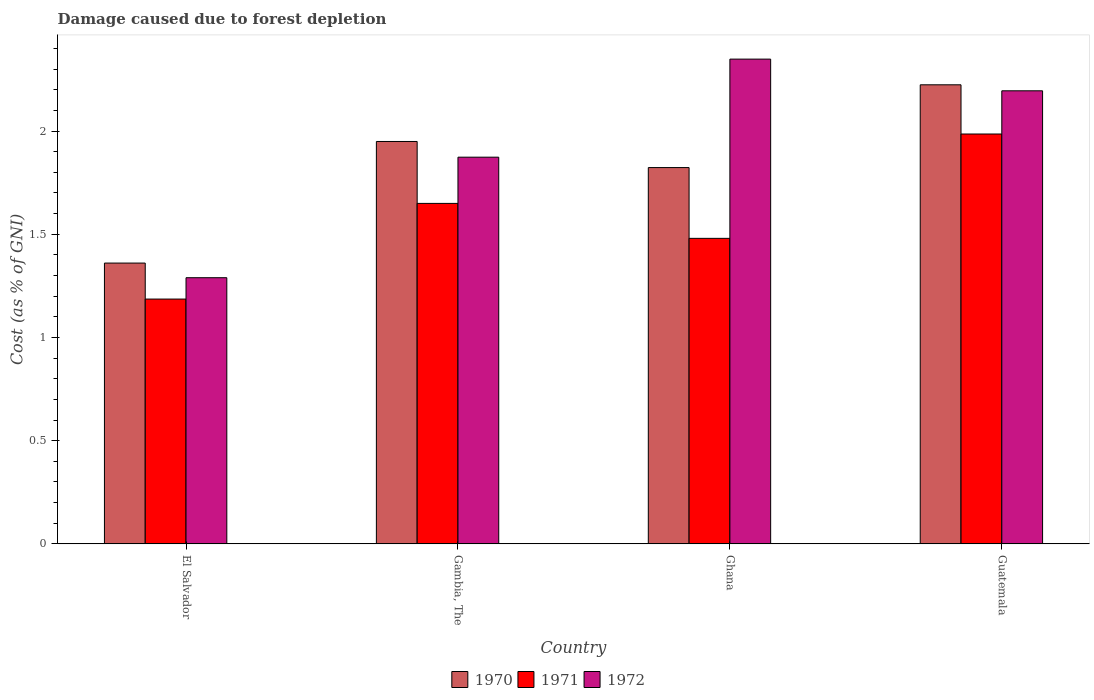How many different coloured bars are there?
Provide a short and direct response. 3. How many groups of bars are there?
Keep it short and to the point. 4. Are the number of bars per tick equal to the number of legend labels?
Keep it short and to the point. Yes. Are the number of bars on each tick of the X-axis equal?
Ensure brevity in your answer.  Yes. How many bars are there on the 4th tick from the left?
Your answer should be very brief. 3. What is the label of the 2nd group of bars from the left?
Give a very brief answer. Gambia, The. In how many cases, is the number of bars for a given country not equal to the number of legend labels?
Make the answer very short. 0. What is the cost of damage caused due to forest depletion in 1970 in Gambia, The?
Your answer should be very brief. 1.95. Across all countries, what is the maximum cost of damage caused due to forest depletion in 1971?
Offer a very short reply. 1.99. Across all countries, what is the minimum cost of damage caused due to forest depletion in 1972?
Your answer should be compact. 1.29. In which country was the cost of damage caused due to forest depletion in 1971 maximum?
Make the answer very short. Guatemala. In which country was the cost of damage caused due to forest depletion in 1971 minimum?
Ensure brevity in your answer.  El Salvador. What is the total cost of damage caused due to forest depletion in 1971 in the graph?
Your answer should be very brief. 6.3. What is the difference between the cost of damage caused due to forest depletion in 1971 in Ghana and that in Guatemala?
Ensure brevity in your answer.  -0.51. What is the difference between the cost of damage caused due to forest depletion in 1970 in Gambia, The and the cost of damage caused due to forest depletion in 1972 in El Salvador?
Keep it short and to the point. 0.66. What is the average cost of damage caused due to forest depletion in 1971 per country?
Keep it short and to the point. 1.58. What is the difference between the cost of damage caused due to forest depletion of/in 1971 and cost of damage caused due to forest depletion of/in 1970 in Guatemala?
Provide a short and direct response. -0.24. What is the ratio of the cost of damage caused due to forest depletion in 1972 in Gambia, The to that in Guatemala?
Your answer should be very brief. 0.85. Is the cost of damage caused due to forest depletion in 1970 in Ghana less than that in Guatemala?
Provide a succinct answer. Yes. What is the difference between the highest and the second highest cost of damage caused due to forest depletion in 1970?
Your response must be concise. -0.27. What is the difference between the highest and the lowest cost of damage caused due to forest depletion in 1970?
Your response must be concise. 0.86. Is the sum of the cost of damage caused due to forest depletion in 1972 in Gambia, The and Guatemala greater than the maximum cost of damage caused due to forest depletion in 1971 across all countries?
Keep it short and to the point. Yes. What does the 2nd bar from the right in El Salvador represents?
Provide a short and direct response. 1971. Is it the case that in every country, the sum of the cost of damage caused due to forest depletion in 1971 and cost of damage caused due to forest depletion in 1972 is greater than the cost of damage caused due to forest depletion in 1970?
Give a very brief answer. Yes. How many bars are there?
Provide a succinct answer. 12. Are all the bars in the graph horizontal?
Your answer should be very brief. No. How many countries are there in the graph?
Your answer should be compact. 4. What is the difference between two consecutive major ticks on the Y-axis?
Provide a succinct answer. 0.5. How many legend labels are there?
Your response must be concise. 3. What is the title of the graph?
Give a very brief answer. Damage caused due to forest depletion. What is the label or title of the X-axis?
Give a very brief answer. Country. What is the label or title of the Y-axis?
Provide a short and direct response. Cost (as % of GNI). What is the Cost (as % of GNI) in 1970 in El Salvador?
Ensure brevity in your answer.  1.36. What is the Cost (as % of GNI) of 1971 in El Salvador?
Offer a terse response. 1.19. What is the Cost (as % of GNI) in 1972 in El Salvador?
Your answer should be very brief. 1.29. What is the Cost (as % of GNI) of 1970 in Gambia, The?
Your answer should be very brief. 1.95. What is the Cost (as % of GNI) of 1971 in Gambia, The?
Ensure brevity in your answer.  1.65. What is the Cost (as % of GNI) of 1972 in Gambia, The?
Your answer should be very brief. 1.87. What is the Cost (as % of GNI) of 1970 in Ghana?
Provide a succinct answer. 1.82. What is the Cost (as % of GNI) in 1971 in Ghana?
Make the answer very short. 1.48. What is the Cost (as % of GNI) in 1972 in Ghana?
Provide a short and direct response. 2.35. What is the Cost (as % of GNI) of 1970 in Guatemala?
Your response must be concise. 2.22. What is the Cost (as % of GNI) of 1971 in Guatemala?
Provide a succinct answer. 1.99. What is the Cost (as % of GNI) of 1972 in Guatemala?
Provide a short and direct response. 2.19. Across all countries, what is the maximum Cost (as % of GNI) in 1970?
Your answer should be very brief. 2.22. Across all countries, what is the maximum Cost (as % of GNI) in 1971?
Provide a short and direct response. 1.99. Across all countries, what is the maximum Cost (as % of GNI) in 1972?
Offer a very short reply. 2.35. Across all countries, what is the minimum Cost (as % of GNI) in 1970?
Offer a terse response. 1.36. Across all countries, what is the minimum Cost (as % of GNI) in 1971?
Give a very brief answer. 1.19. Across all countries, what is the minimum Cost (as % of GNI) of 1972?
Ensure brevity in your answer.  1.29. What is the total Cost (as % of GNI) of 1970 in the graph?
Provide a succinct answer. 7.36. What is the total Cost (as % of GNI) in 1971 in the graph?
Your answer should be compact. 6.3. What is the total Cost (as % of GNI) of 1972 in the graph?
Offer a terse response. 7.71. What is the difference between the Cost (as % of GNI) in 1970 in El Salvador and that in Gambia, The?
Provide a short and direct response. -0.59. What is the difference between the Cost (as % of GNI) of 1971 in El Salvador and that in Gambia, The?
Offer a very short reply. -0.46. What is the difference between the Cost (as % of GNI) in 1972 in El Salvador and that in Gambia, The?
Give a very brief answer. -0.58. What is the difference between the Cost (as % of GNI) in 1970 in El Salvador and that in Ghana?
Your response must be concise. -0.46. What is the difference between the Cost (as % of GNI) in 1971 in El Salvador and that in Ghana?
Your answer should be very brief. -0.29. What is the difference between the Cost (as % of GNI) in 1972 in El Salvador and that in Ghana?
Make the answer very short. -1.06. What is the difference between the Cost (as % of GNI) in 1970 in El Salvador and that in Guatemala?
Keep it short and to the point. -0.86. What is the difference between the Cost (as % of GNI) of 1971 in El Salvador and that in Guatemala?
Your answer should be compact. -0.8. What is the difference between the Cost (as % of GNI) of 1972 in El Salvador and that in Guatemala?
Offer a very short reply. -0.91. What is the difference between the Cost (as % of GNI) in 1970 in Gambia, The and that in Ghana?
Offer a very short reply. 0.13. What is the difference between the Cost (as % of GNI) of 1971 in Gambia, The and that in Ghana?
Give a very brief answer. 0.17. What is the difference between the Cost (as % of GNI) of 1972 in Gambia, The and that in Ghana?
Provide a succinct answer. -0.48. What is the difference between the Cost (as % of GNI) in 1970 in Gambia, The and that in Guatemala?
Keep it short and to the point. -0.27. What is the difference between the Cost (as % of GNI) of 1971 in Gambia, The and that in Guatemala?
Ensure brevity in your answer.  -0.34. What is the difference between the Cost (as % of GNI) of 1972 in Gambia, The and that in Guatemala?
Your answer should be compact. -0.32. What is the difference between the Cost (as % of GNI) in 1970 in Ghana and that in Guatemala?
Your answer should be compact. -0.4. What is the difference between the Cost (as % of GNI) in 1971 in Ghana and that in Guatemala?
Ensure brevity in your answer.  -0.51. What is the difference between the Cost (as % of GNI) in 1972 in Ghana and that in Guatemala?
Your response must be concise. 0.15. What is the difference between the Cost (as % of GNI) of 1970 in El Salvador and the Cost (as % of GNI) of 1971 in Gambia, The?
Offer a terse response. -0.29. What is the difference between the Cost (as % of GNI) of 1970 in El Salvador and the Cost (as % of GNI) of 1972 in Gambia, The?
Make the answer very short. -0.51. What is the difference between the Cost (as % of GNI) in 1971 in El Salvador and the Cost (as % of GNI) in 1972 in Gambia, The?
Provide a short and direct response. -0.69. What is the difference between the Cost (as % of GNI) of 1970 in El Salvador and the Cost (as % of GNI) of 1971 in Ghana?
Ensure brevity in your answer.  -0.12. What is the difference between the Cost (as % of GNI) of 1970 in El Salvador and the Cost (as % of GNI) of 1972 in Ghana?
Keep it short and to the point. -0.99. What is the difference between the Cost (as % of GNI) in 1971 in El Salvador and the Cost (as % of GNI) in 1972 in Ghana?
Offer a very short reply. -1.16. What is the difference between the Cost (as % of GNI) of 1970 in El Salvador and the Cost (as % of GNI) of 1971 in Guatemala?
Keep it short and to the point. -0.63. What is the difference between the Cost (as % of GNI) of 1970 in El Salvador and the Cost (as % of GNI) of 1972 in Guatemala?
Provide a short and direct response. -0.83. What is the difference between the Cost (as % of GNI) in 1971 in El Salvador and the Cost (as % of GNI) in 1972 in Guatemala?
Keep it short and to the point. -1.01. What is the difference between the Cost (as % of GNI) of 1970 in Gambia, The and the Cost (as % of GNI) of 1971 in Ghana?
Your response must be concise. 0.47. What is the difference between the Cost (as % of GNI) in 1970 in Gambia, The and the Cost (as % of GNI) in 1972 in Ghana?
Offer a terse response. -0.4. What is the difference between the Cost (as % of GNI) of 1971 in Gambia, The and the Cost (as % of GNI) of 1972 in Ghana?
Your answer should be very brief. -0.7. What is the difference between the Cost (as % of GNI) of 1970 in Gambia, The and the Cost (as % of GNI) of 1971 in Guatemala?
Your answer should be compact. -0.04. What is the difference between the Cost (as % of GNI) of 1970 in Gambia, The and the Cost (as % of GNI) of 1972 in Guatemala?
Your answer should be compact. -0.25. What is the difference between the Cost (as % of GNI) in 1971 in Gambia, The and the Cost (as % of GNI) in 1972 in Guatemala?
Ensure brevity in your answer.  -0.55. What is the difference between the Cost (as % of GNI) in 1970 in Ghana and the Cost (as % of GNI) in 1971 in Guatemala?
Give a very brief answer. -0.16. What is the difference between the Cost (as % of GNI) in 1970 in Ghana and the Cost (as % of GNI) in 1972 in Guatemala?
Your answer should be compact. -0.37. What is the difference between the Cost (as % of GNI) in 1971 in Ghana and the Cost (as % of GNI) in 1972 in Guatemala?
Ensure brevity in your answer.  -0.71. What is the average Cost (as % of GNI) in 1970 per country?
Offer a terse response. 1.84. What is the average Cost (as % of GNI) of 1971 per country?
Your response must be concise. 1.58. What is the average Cost (as % of GNI) in 1972 per country?
Your answer should be very brief. 1.93. What is the difference between the Cost (as % of GNI) of 1970 and Cost (as % of GNI) of 1971 in El Salvador?
Keep it short and to the point. 0.17. What is the difference between the Cost (as % of GNI) in 1970 and Cost (as % of GNI) in 1972 in El Salvador?
Offer a very short reply. 0.07. What is the difference between the Cost (as % of GNI) of 1971 and Cost (as % of GNI) of 1972 in El Salvador?
Keep it short and to the point. -0.1. What is the difference between the Cost (as % of GNI) in 1970 and Cost (as % of GNI) in 1972 in Gambia, The?
Give a very brief answer. 0.08. What is the difference between the Cost (as % of GNI) of 1971 and Cost (as % of GNI) of 1972 in Gambia, The?
Provide a short and direct response. -0.22. What is the difference between the Cost (as % of GNI) in 1970 and Cost (as % of GNI) in 1971 in Ghana?
Provide a succinct answer. 0.34. What is the difference between the Cost (as % of GNI) in 1970 and Cost (as % of GNI) in 1972 in Ghana?
Provide a short and direct response. -0.53. What is the difference between the Cost (as % of GNI) in 1971 and Cost (as % of GNI) in 1972 in Ghana?
Provide a succinct answer. -0.87. What is the difference between the Cost (as % of GNI) of 1970 and Cost (as % of GNI) of 1971 in Guatemala?
Ensure brevity in your answer.  0.24. What is the difference between the Cost (as % of GNI) in 1970 and Cost (as % of GNI) in 1972 in Guatemala?
Provide a short and direct response. 0.03. What is the difference between the Cost (as % of GNI) of 1971 and Cost (as % of GNI) of 1972 in Guatemala?
Offer a terse response. -0.21. What is the ratio of the Cost (as % of GNI) in 1970 in El Salvador to that in Gambia, The?
Provide a short and direct response. 0.7. What is the ratio of the Cost (as % of GNI) in 1971 in El Salvador to that in Gambia, The?
Offer a very short reply. 0.72. What is the ratio of the Cost (as % of GNI) in 1972 in El Salvador to that in Gambia, The?
Ensure brevity in your answer.  0.69. What is the ratio of the Cost (as % of GNI) of 1970 in El Salvador to that in Ghana?
Make the answer very short. 0.75. What is the ratio of the Cost (as % of GNI) in 1971 in El Salvador to that in Ghana?
Make the answer very short. 0.8. What is the ratio of the Cost (as % of GNI) in 1972 in El Salvador to that in Ghana?
Give a very brief answer. 0.55. What is the ratio of the Cost (as % of GNI) in 1970 in El Salvador to that in Guatemala?
Offer a terse response. 0.61. What is the ratio of the Cost (as % of GNI) of 1971 in El Salvador to that in Guatemala?
Provide a succinct answer. 0.6. What is the ratio of the Cost (as % of GNI) in 1972 in El Salvador to that in Guatemala?
Your answer should be very brief. 0.59. What is the ratio of the Cost (as % of GNI) in 1970 in Gambia, The to that in Ghana?
Ensure brevity in your answer.  1.07. What is the ratio of the Cost (as % of GNI) of 1971 in Gambia, The to that in Ghana?
Give a very brief answer. 1.11. What is the ratio of the Cost (as % of GNI) in 1972 in Gambia, The to that in Ghana?
Your answer should be compact. 0.8. What is the ratio of the Cost (as % of GNI) in 1970 in Gambia, The to that in Guatemala?
Provide a succinct answer. 0.88. What is the ratio of the Cost (as % of GNI) in 1971 in Gambia, The to that in Guatemala?
Keep it short and to the point. 0.83. What is the ratio of the Cost (as % of GNI) of 1972 in Gambia, The to that in Guatemala?
Give a very brief answer. 0.85. What is the ratio of the Cost (as % of GNI) in 1970 in Ghana to that in Guatemala?
Make the answer very short. 0.82. What is the ratio of the Cost (as % of GNI) of 1971 in Ghana to that in Guatemala?
Give a very brief answer. 0.75. What is the ratio of the Cost (as % of GNI) in 1972 in Ghana to that in Guatemala?
Give a very brief answer. 1.07. What is the difference between the highest and the second highest Cost (as % of GNI) of 1970?
Your answer should be very brief. 0.27. What is the difference between the highest and the second highest Cost (as % of GNI) of 1971?
Ensure brevity in your answer.  0.34. What is the difference between the highest and the second highest Cost (as % of GNI) of 1972?
Make the answer very short. 0.15. What is the difference between the highest and the lowest Cost (as % of GNI) in 1970?
Offer a very short reply. 0.86. What is the difference between the highest and the lowest Cost (as % of GNI) in 1971?
Offer a terse response. 0.8. What is the difference between the highest and the lowest Cost (as % of GNI) of 1972?
Provide a short and direct response. 1.06. 